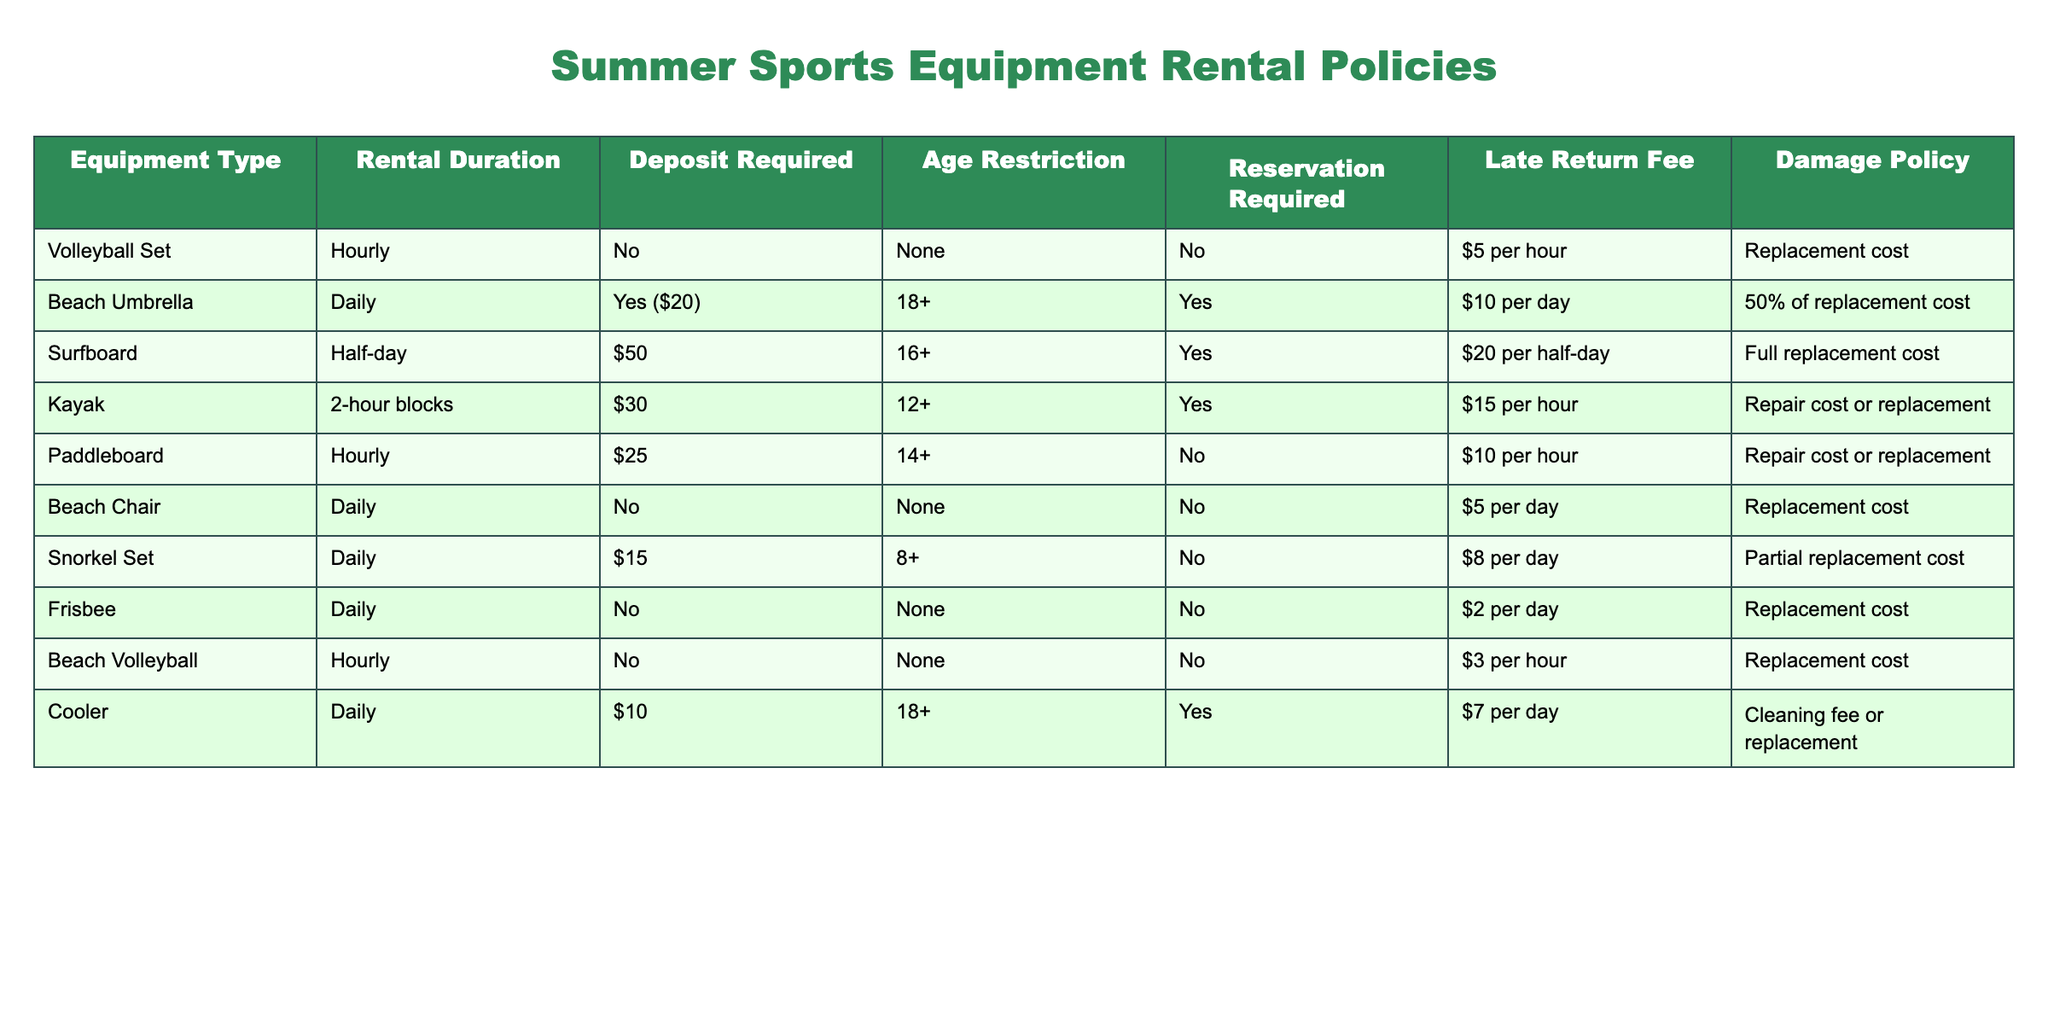What equipment requires a deposit for rental? By examining the table, we can see that the "Beach Umbrella" and "Cooler" display a requirement for a deposit. Specifically, the Beach Umbrella requires a deposit of $20, while the Cooler requires no deposit.
Answer: Beach Umbrella, Cooler Is there an age restriction for renting a surfboard? The table indicates that the Surfboard has a specific age restriction listed as 16+. This means individuals must be at least 16 years old to rent the surfboard.
Answer: Yes How much would it cost to rent a beach chair for a week? Renting a Beach Chair costs $5 per day. For a week (7 days), the total cost would be calculated as 5 * 7 = 35. Therefore, the cost to rent for a week amounts to $35.
Answer: 35 What is the late return fee for a kayak rental? The table states that for a kayak rental, the late return fee is set at $15 per hour. Hence, if a rental period is exceeded, this fee will apply.
Answer: $15 per hour Which equipment has the highest damage policy percentage? Based on the table, the Surfboard displays a damage policy of "Full replacement cost," indicating that if damaged, the entire cost of replacing the surfboard is the responsibility of the renter. This is the strictest policy noted.
Answer: Surfboard How much deposit refund can a 17-year-old expect when renting a beach umbrella? The Beach Umbrella requires a deposit of $20, and there is no age restriction listed for refund eligibility. Assuming no damage, the full deposit will be refunded.
Answer: $20 What is the average late return fee for all equipment listed? The late return fees are: Volleyball Set $5, Beach Umbrella $10, Surfboard $20, Kayak $15, Paddleboard $10, Beach Chair $5, Snorkel Set $8, Frisbee $2, Beach Volleyball $3, and Cooler $7. Summing these values gives 5 + 10 + 20 + 15 + 10 + 5 + 8 + 2 + 3 + 7 = 85. There are 10 pieces of equipment, so the average is 85 / 10 = 8.5.
Answer: 8.5 Can a 12-year-old rent a kayak? The age restriction for renting a kayak is set at 12+ according to the table, which implies that a 12-year-old can indeed rent a kayak.
Answer: Yes Which equipment does not require a reservation? According to the table, the equipment types that do not require a reservation are: Volleyball Set, Beach Chair, Snorkel Set, Frisbee, and Beach Volleyball.
Answer: Volleyball Set, Beach Chair, Snorkel Set, Frisbee, Beach Volleyball 